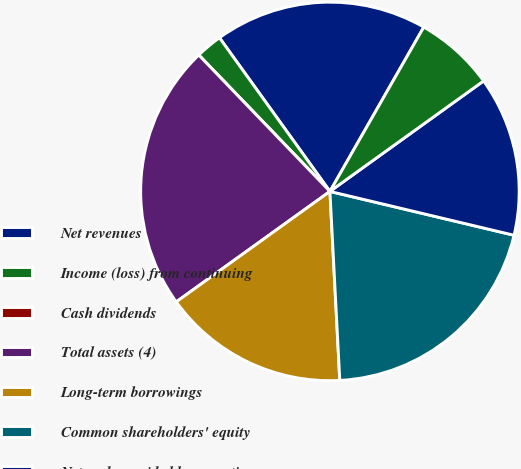Convert chart. <chart><loc_0><loc_0><loc_500><loc_500><pie_chart><fcel>Net revenues<fcel>Income (loss) from continuing<fcel>Cash dividends<fcel>Total assets (4)<fcel>Long-term borrowings<fcel>Common shareholders' equity<fcel>Net cash provided by operating<fcel>Net cash (used in) provided by<nl><fcel>18.18%<fcel>2.27%<fcel>0.0%<fcel>22.73%<fcel>15.91%<fcel>20.45%<fcel>13.64%<fcel>6.82%<nl></chart> 